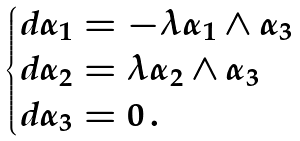Convert formula to latex. <formula><loc_0><loc_0><loc_500><loc_500>\begin{cases} d \alpha _ { 1 } = - \lambda \alpha _ { 1 } \wedge \alpha _ { 3 } \\ d \alpha _ { 2 } = \lambda \alpha _ { 2 } \wedge \alpha _ { 3 } \\ d \alpha _ { 3 } = 0 \, . \end{cases}</formula> 